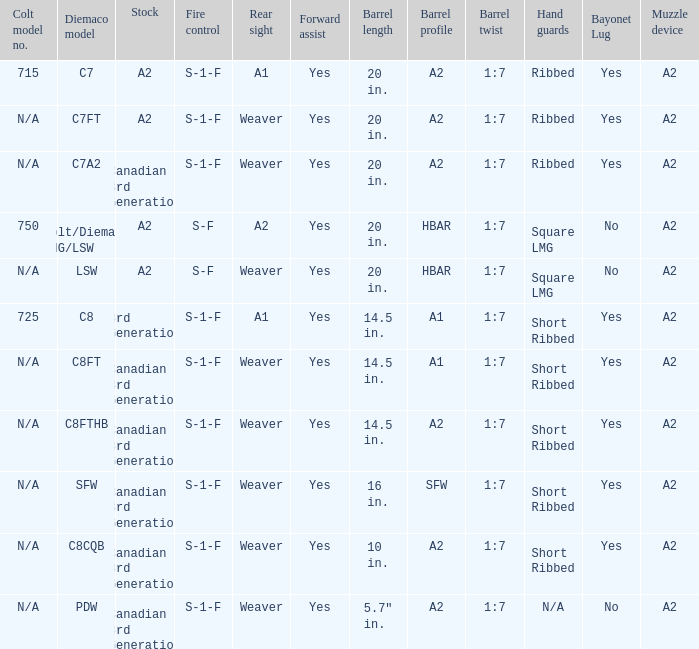Which hand guards possess an a2 barrel profile and come with a weaver rear sight? Ribbed, Ribbed, Short Ribbed, Short Ribbed, N/A. 